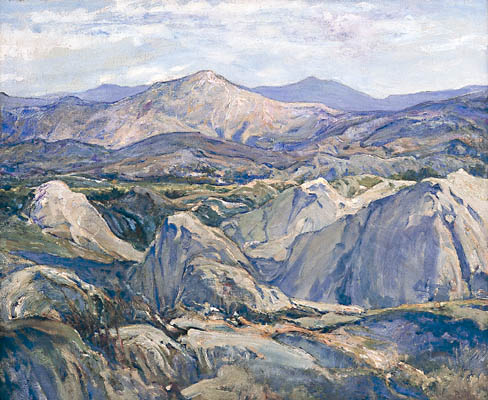Explain the visual content of the image in great detail. The image is an evocative portrayal of a mountainous region, executed in a style reminiscent of impressionism. The artist employs a primarily cool color palette, with a dominance of blues, greens, and grays. Subtle accents of purple and orange are interspersed, adding a rich depth and contrast to the overall composition. The absence of human-made structures underscores a deliberate focus on the untouched natural landscape.

The mountains in the background loom grandly, their peaks kissed by a soft purple hue that imparts a sense of distance and enigmatic allure. In the midground, rolling hills and valleys are painted in varied shades of blue-green, creating a harmonious contrast with the majestic mountains behind them.

The artist’s technique of using loose, expressive brushstrokes is emblematic of the impressionist movement, prioritizing the capture of mood and atmosphere over precise detail. This approach imbues the landscape with a dynamic, almost ethereal quality, suggesting an environment that is alive and constantly changing with the light.

Overall, the painting is a captivating rendition of the natural world, encapsulating the serene and timeless beauty of a mountainous landscape with masterful use of color and texture. 